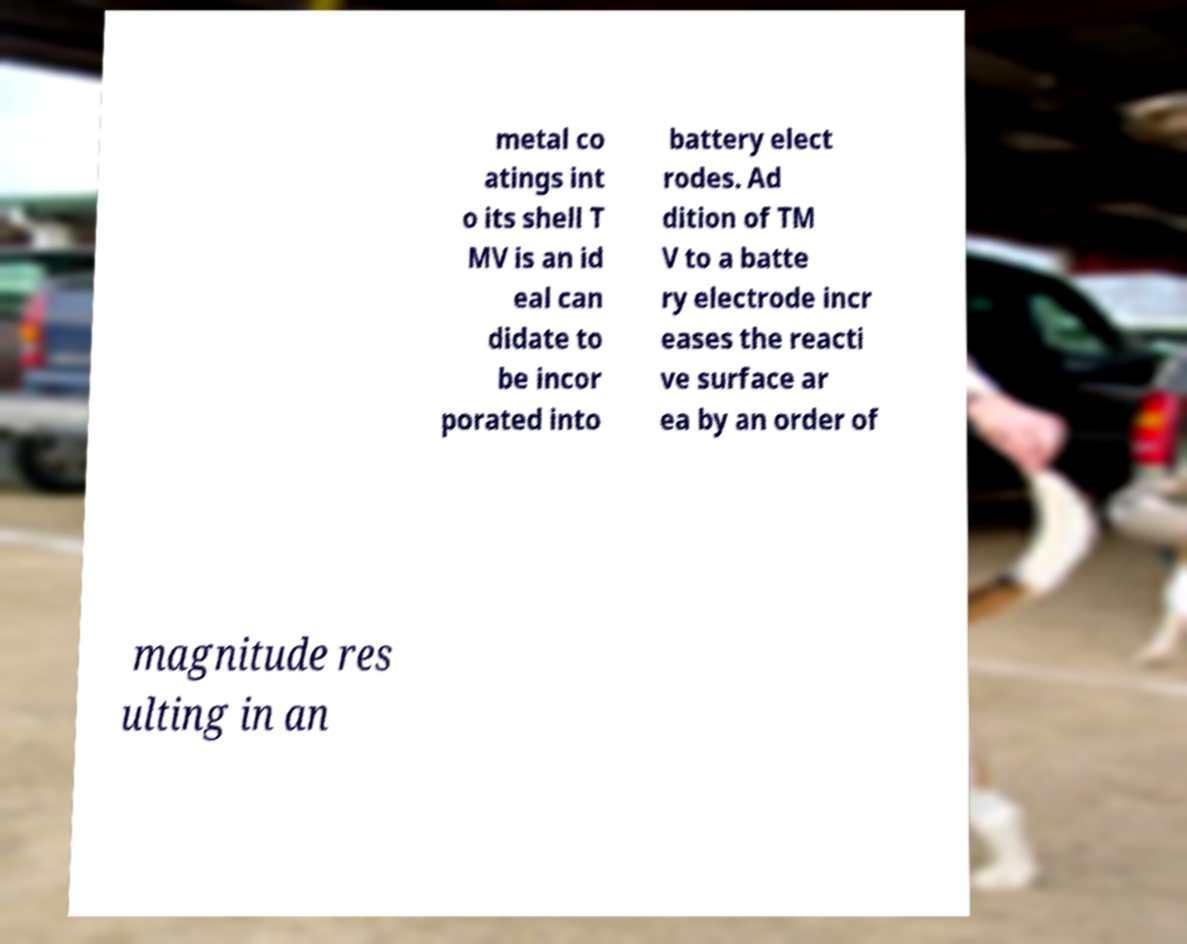Please identify and transcribe the text found in this image. metal co atings int o its shell T MV is an id eal can didate to be incor porated into battery elect rodes. Ad dition of TM V to a batte ry electrode incr eases the reacti ve surface ar ea by an order of magnitude res ulting in an 